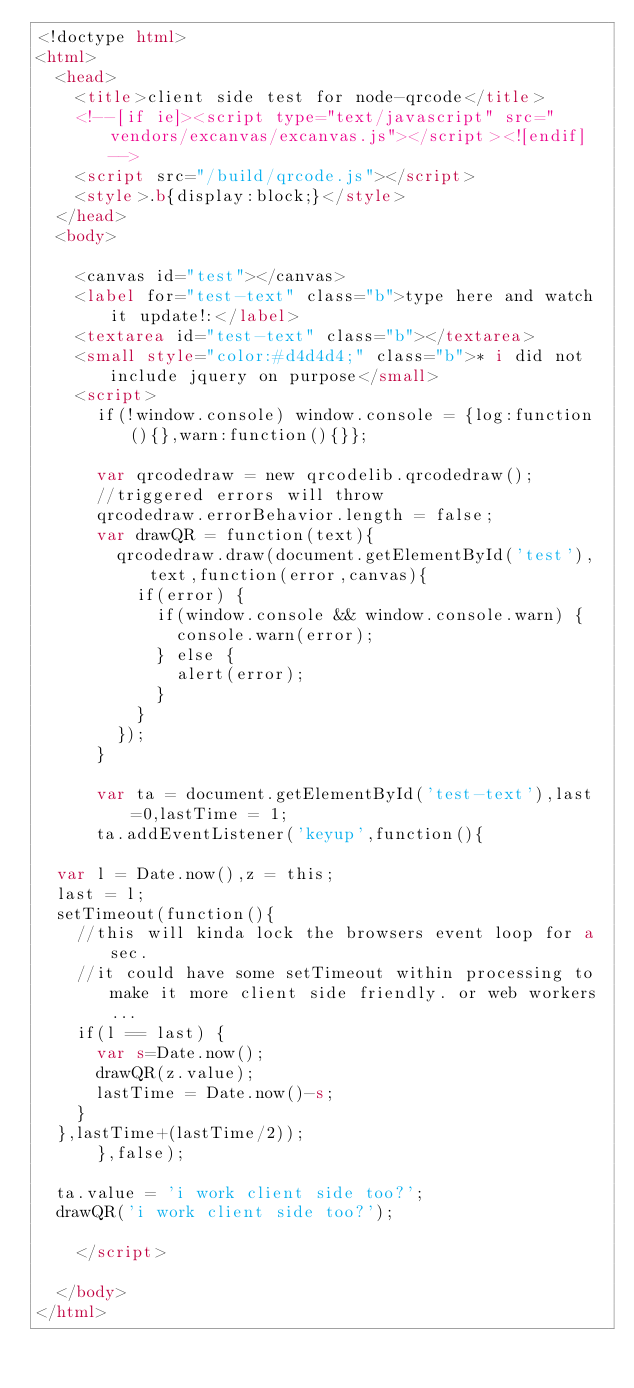Convert code to text. <code><loc_0><loc_0><loc_500><loc_500><_HTML_><!doctype html>
<html>
	<head>
		<title>client side test for node-qrcode</title>
    <!--[if ie]><script type="text/javascript" src="vendors/excanvas/excanvas.js"></script><![endif]-->
		<script src="/build/qrcode.js"></script>
		<style>.b{display:block;}</style>
	</head>
	<body>

		<canvas id="test"></canvas>
		<label for="test-text" class="b">type here and watch it update!:</label>
		<textarea id="test-text" class="b"></textarea>
		<small style="color:#d4d4d4;" class="b">* i did not include jquery on purpose</small>
		<script>
      if(!window.console) window.console = {log:function(){},warn:function(){}};

      var qrcodedraw = new qrcodelib.qrcodedraw();
      //triggered errors will throw
      qrcodedraw.errorBehavior.length = false;
      var drawQR = function(text){
        qrcodedraw.draw(document.getElementById('test'),text,function(error,canvas){
          if(error) {
            if(window.console && window.console.warn) {
              console.warn(error);
            } else {
              alert(error);
            }
          }
        });
      }

      var ta = document.getElementById('test-text'),last=0,lastTime = 1;
      ta.addEventListener('keyup',function(){

  var l = Date.now(),z = this;
  last = l;
  setTimeout(function(){
    //this will kinda lock the browsers event loop for a sec.
    //it could have some setTimeout within processing to make it more client side friendly. or web workers...
    if(l == last) {
      var s=Date.now();
      drawQR(z.value);
      lastTime = Date.now()-s;
    }
  },lastTime+(lastTime/2));
      },false);

  ta.value = 'i work client side too?';
  drawQR('i work client side too?');

		</script>

	</body>
</html>
</code> 